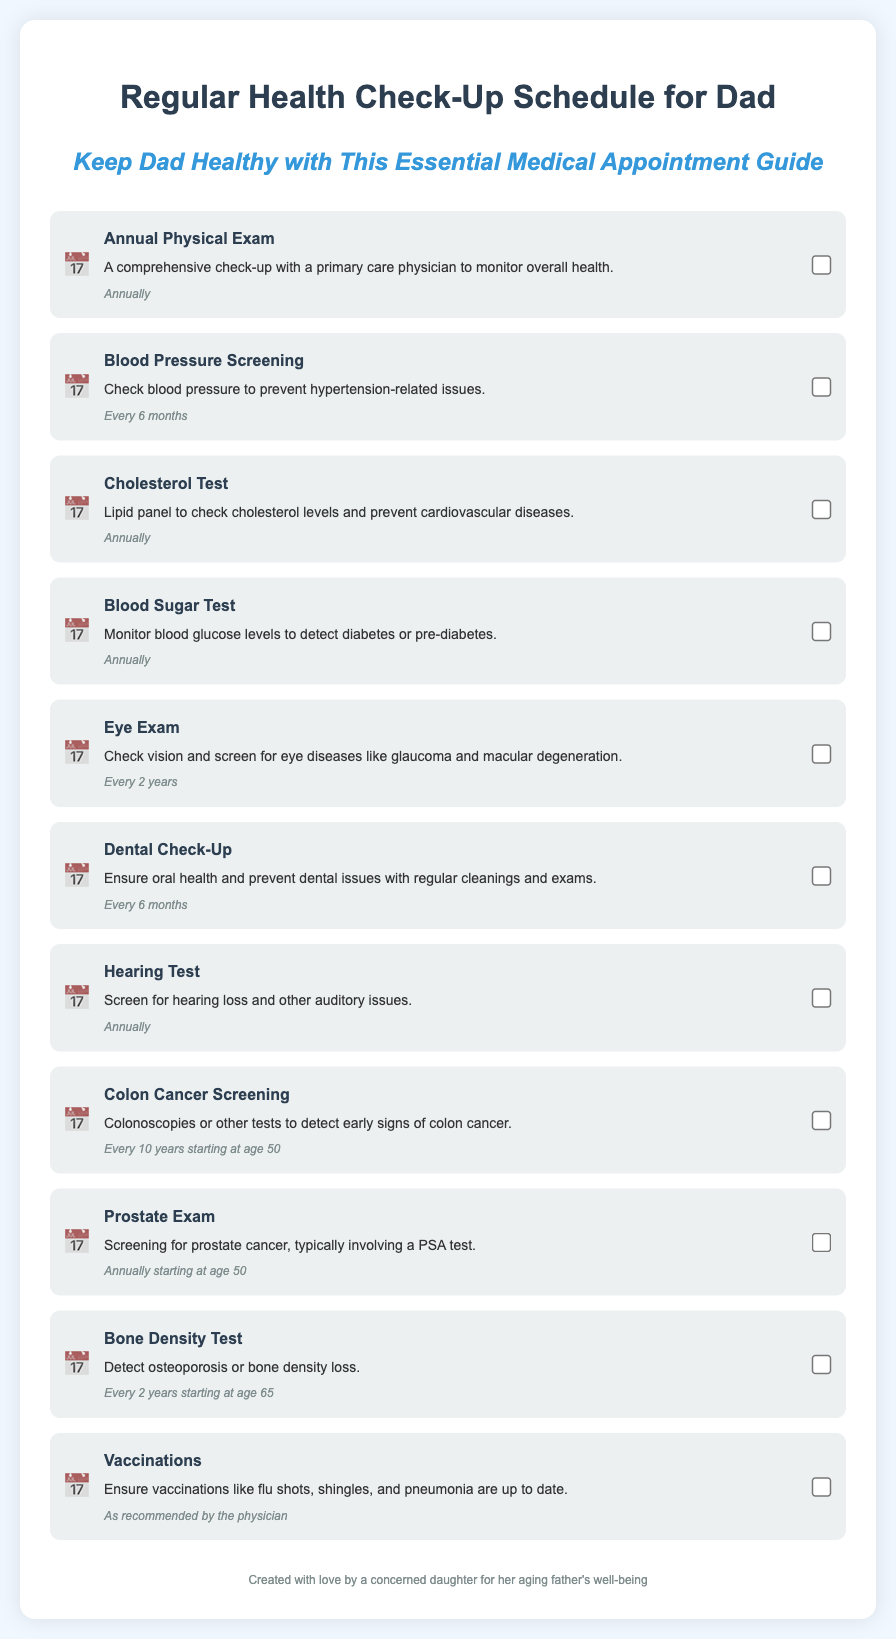What is the title of the first appointment? The title of the first appointment is located at the beginning of the first appointment item in the list.
Answer: Annual Physical Exam How often should Dad have a Blood Pressure Screening? The frequency of the Blood Pressure Screening is stated in the appointment item.
Answer: Every 6 months At what age should the Colon Cancer Screening begin? The age to begin the Colon Cancer Screening is mentioned in the description of the appointment item.
Answer: 50 What type of test is done to monitor blood glucose levels? The specific test related to monitoring blood glucose levels is provided in the appointment description.
Answer: Blood Sugar Test How frequently should a Dental Check-Up be performed? The frequency for the Dental Check-Up is included in the appointment details.
Answer: Every 6 months What is the purpose of the Eye Exam? The purpose is described in the content of the Eye Exam appointment item.
Answer: Check vision and screen for eye diseases How many years apart is the Bone Density Test recommended? The interval for the Bone Density Test is listed in the appointment frequency.
Answer: Every 2 years What vaccinations should be ensured according to the schedule? The vaccinations to be ensured are mentioned in the appointment description for vaccinations.
Answer: Flu shots, shingles, and pneumonia When should a Prostate Exam start? The starting age for the Prostate Exam is mentioned in the appointment item.
Answer: 50 